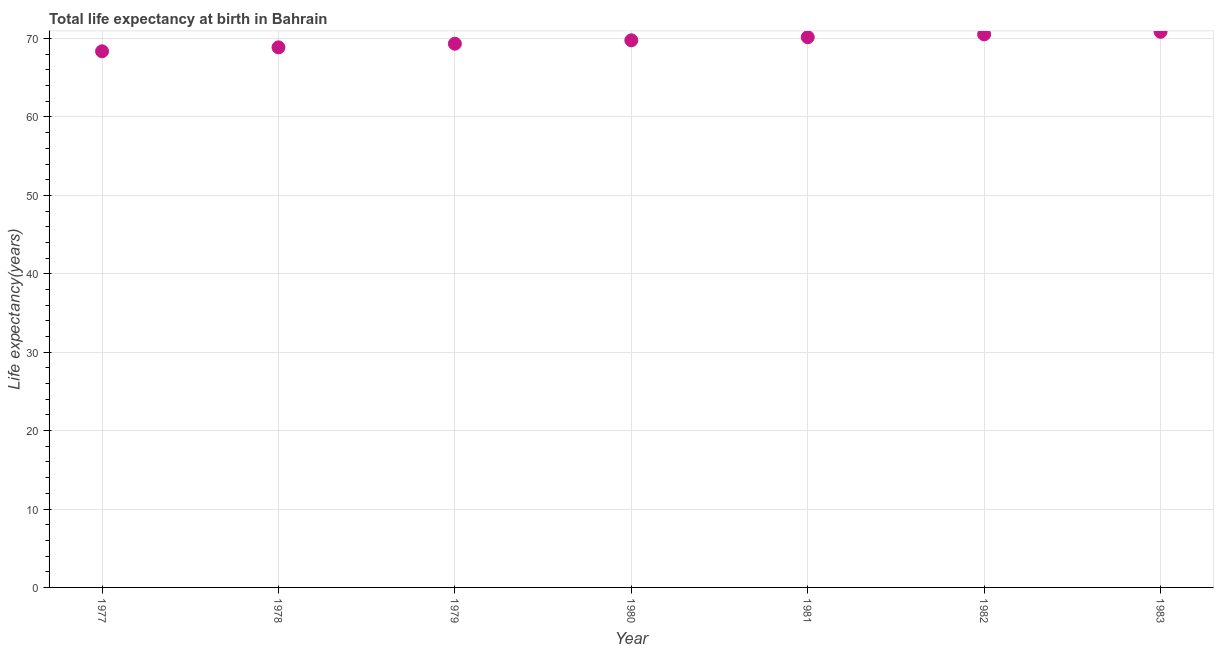What is the life expectancy at birth in 1983?
Your answer should be very brief. 70.86. Across all years, what is the maximum life expectancy at birth?
Ensure brevity in your answer.  70.86. Across all years, what is the minimum life expectancy at birth?
Offer a terse response. 68.38. What is the sum of the life expectancy at birth?
Make the answer very short. 487.96. What is the difference between the life expectancy at birth in 1979 and 1983?
Your answer should be very brief. -1.52. What is the average life expectancy at birth per year?
Make the answer very short. 69.71. What is the median life expectancy at birth?
Your answer should be very brief. 69.78. Do a majority of the years between 1978 and 1983 (inclusive) have life expectancy at birth greater than 12 years?
Your response must be concise. Yes. What is the ratio of the life expectancy at birth in 1978 to that in 1979?
Your response must be concise. 0.99. Is the life expectancy at birth in 1978 less than that in 1981?
Give a very brief answer. Yes. What is the difference between the highest and the second highest life expectancy at birth?
Offer a terse response. 0.33. What is the difference between the highest and the lowest life expectancy at birth?
Your response must be concise. 2.49. In how many years, is the life expectancy at birth greater than the average life expectancy at birth taken over all years?
Provide a short and direct response. 4. Does the life expectancy at birth monotonically increase over the years?
Make the answer very short. Yes. What is the difference between two consecutive major ticks on the Y-axis?
Make the answer very short. 10. What is the title of the graph?
Ensure brevity in your answer.  Total life expectancy at birth in Bahrain. What is the label or title of the X-axis?
Give a very brief answer. Year. What is the label or title of the Y-axis?
Make the answer very short. Life expectancy(years). What is the Life expectancy(years) in 1977?
Make the answer very short. 68.38. What is the Life expectancy(years) in 1978?
Ensure brevity in your answer.  68.88. What is the Life expectancy(years) in 1979?
Your answer should be compact. 69.35. What is the Life expectancy(years) in 1980?
Provide a succinct answer. 69.78. What is the Life expectancy(years) in 1981?
Give a very brief answer. 70.18. What is the Life expectancy(years) in 1982?
Offer a very short reply. 70.54. What is the Life expectancy(years) in 1983?
Ensure brevity in your answer.  70.86. What is the difference between the Life expectancy(years) in 1977 and 1978?
Your answer should be compact. -0.5. What is the difference between the Life expectancy(years) in 1977 and 1979?
Your answer should be very brief. -0.97. What is the difference between the Life expectancy(years) in 1977 and 1980?
Your response must be concise. -1.4. What is the difference between the Life expectancy(years) in 1977 and 1981?
Give a very brief answer. -1.8. What is the difference between the Life expectancy(years) in 1977 and 1982?
Provide a succinct answer. -2.16. What is the difference between the Life expectancy(years) in 1977 and 1983?
Offer a terse response. -2.49. What is the difference between the Life expectancy(years) in 1978 and 1979?
Offer a very short reply. -0.47. What is the difference between the Life expectancy(years) in 1978 and 1980?
Provide a short and direct response. -0.9. What is the difference between the Life expectancy(years) in 1978 and 1981?
Your answer should be very brief. -1.3. What is the difference between the Life expectancy(years) in 1978 and 1982?
Your response must be concise. -1.66. What is the difference between the Life expectancy(years) in 1978 and 1983?
Ensure brevity in your answer.  -1.99. What is the difference between the Life expectancy(years) in 1979 and 1980?
Provide a succinct answer. -0.43. What is the difference between the Life expectancy(years) in 1979 and 1981?
Your response must be concise. -0.83. What is the difference between the Life expectancy(years) in 1979 and 1982?
Make the answer very short. -1.19. What is the difference between the Life expectancy(years) in 1979 and 1983?
Provide a short and direct response. -1.52. What is the difference between the Life expectancy(years) in 1980 and 1981?
Your answer should be very brief. -0.4. What is the difference between the Life expectancy(years) in 1980 and 1982?
Offer a very short reply. -0.76. What is the difference between the Life expectancy(years) in 1980 and 1983?
Give a very brief answer. -1.09. What is the difference between the Life expectancy(years) in 1981 and 1982?
Offer a terse response. -0.36. What is the difference between the Life expectancy(years) in 1981 and 1983?
Keep it short and to the point. -0.69. What is the difference between the Life expectancy(years) in 1982 and 1983?
Make the answer very short. -0.33. What is the ratio of the Life expectancy(years) in 1977 to that in 1978?
Make the answer very short. 0.99. What is the ratio of the Life expectancy(years) in 1977 to that in 1979?
Make the answer very short. 0.99. What is the ratio of the Life expectancy(years) in 1978 to that in 1980?
Your answer should be very brief. 0.99. What is the ratio of the Life expectancy(years) in 1979 to that in 1980?
Your answer should be compact. 0.99. What is the ratio of the Life expectancy(years) in 1982 to that in 1983?
Offer a terse response. 0.99. 